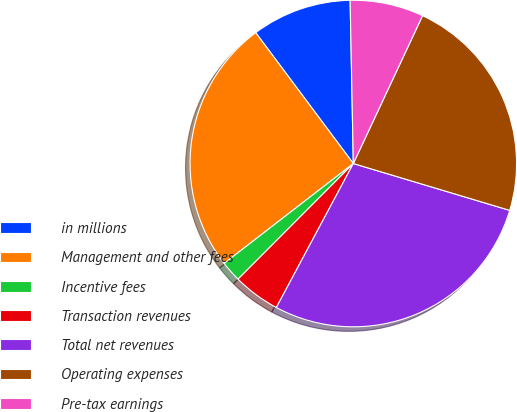Convert chart to OTSL. <chart><loc_0><loc_0><loc_500><loc_500><pie_chart><fcel>in millions<fcel>Management and other fees<fcel>Incentive fees<fcel>Transaction revenues<fcel>Total net revenues<fcel>Operating expenses<fcel>Pre-tax earnings<nl><fcel>9.89%<fcel>25.27%<fcel>2.05%<fcel>4.66%<fcel>28.18%<fcel>22.66%<fcel>7.28%<nl></chart> 